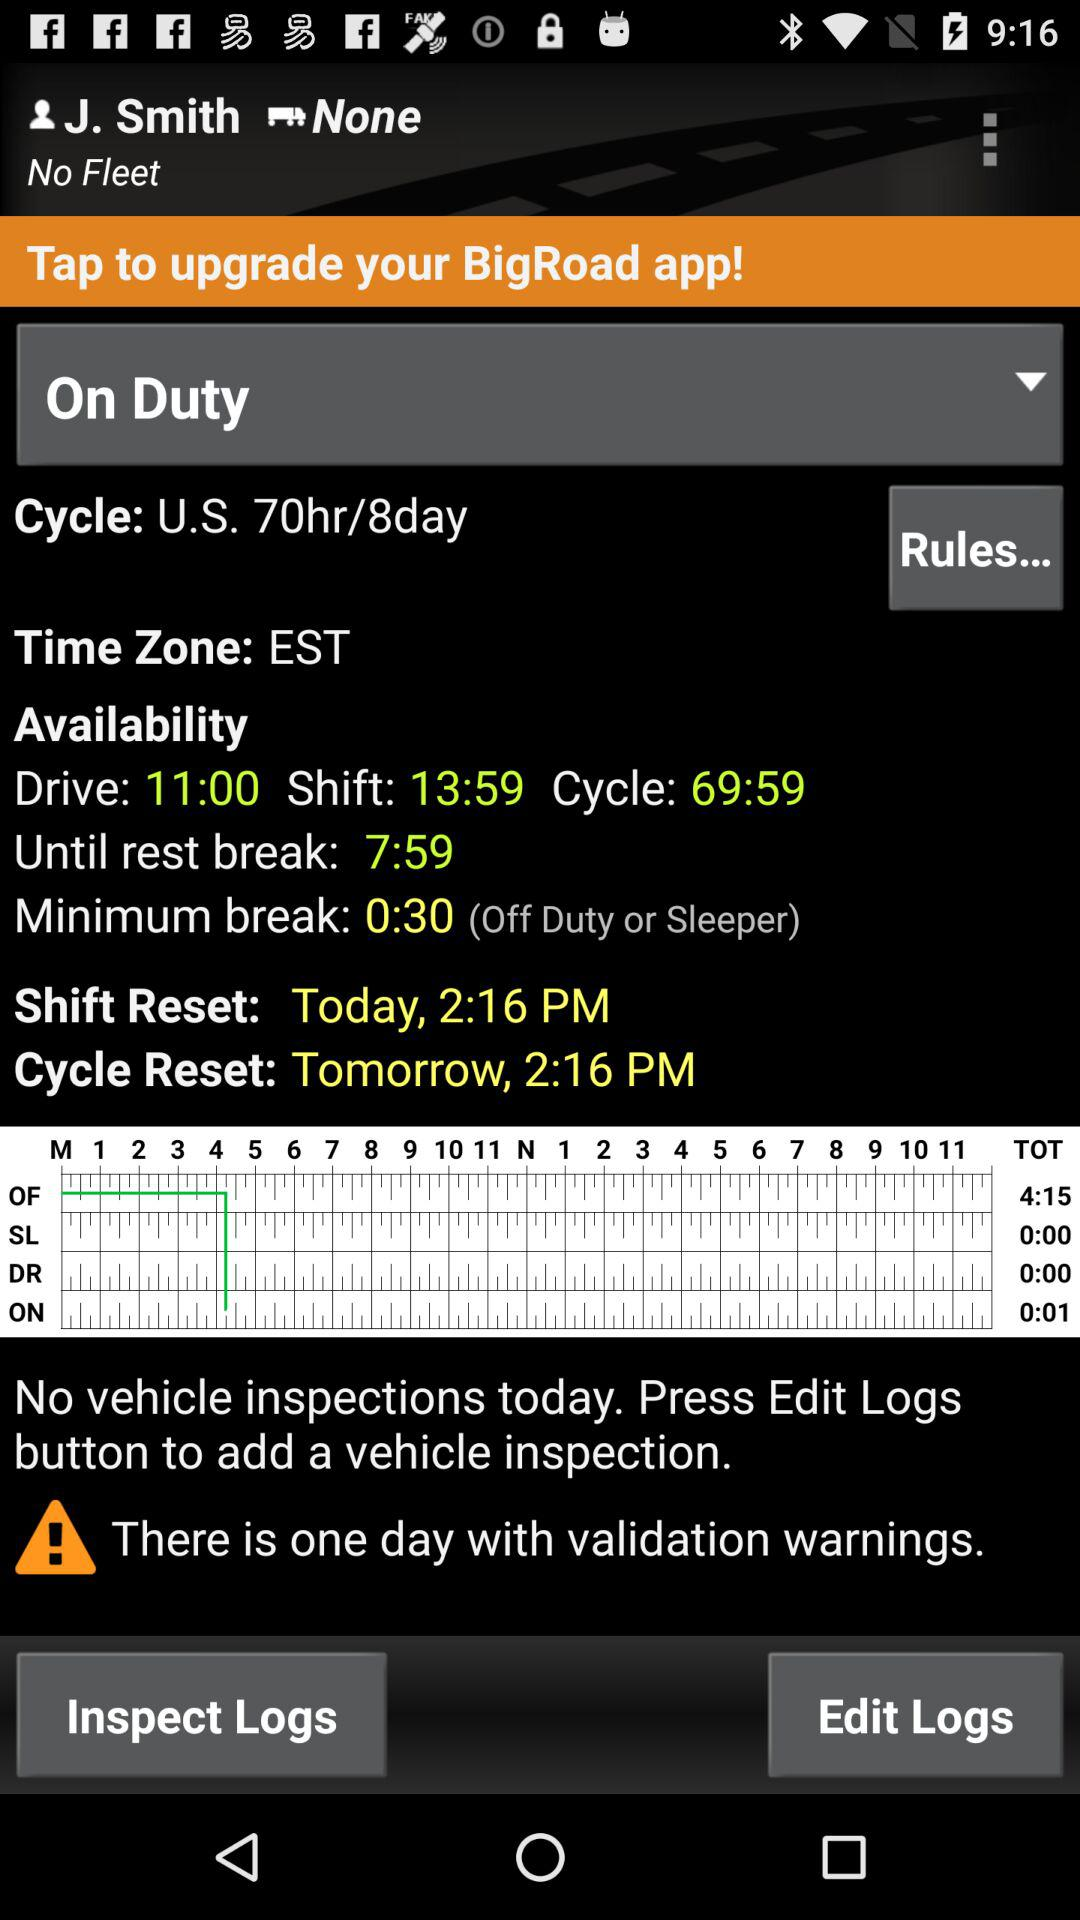What is price of cycle U.S per 8 day?
When the provided information is insufficient, respond with <no answer>. <no answer> 